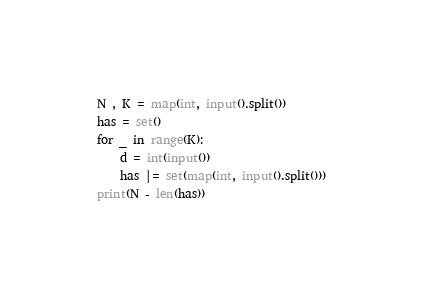<code> <loc_0><loc_0><loc_500><loc_500><_Python_>N , K = map(int, input().split())
has = set()
for _ in range(K):
    d = int(input())
    has |= set(map(int, input().split()))
print(N - len(has))</code> 